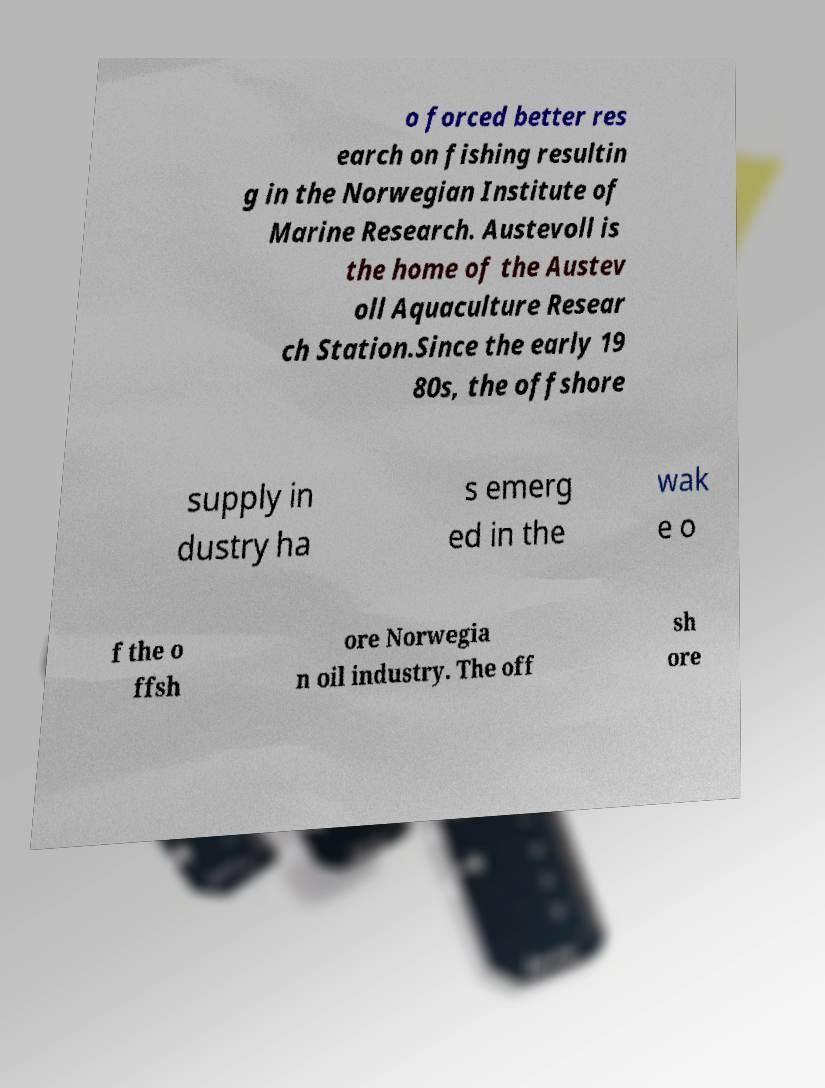What messages or text are displayed in this image? I need them in a readable, typed format. o forced better res earch on fishing resultin g in the Norwegian Institute of Marine Research. Austevoll is the home of the Austev oll Aquaculture Resear ch Station.Since the early 19 80s, the offshore supply in dustry ha s emerg ed in the wak e o f the o ffsh ore Norwegia n oil industry. The off sh ore 